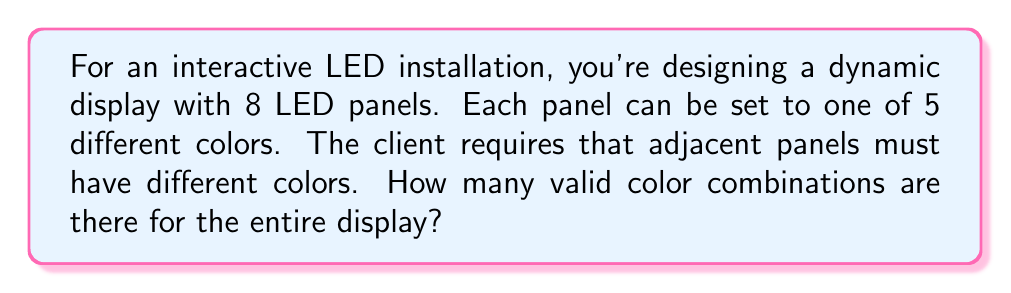Provide a solution to this math problem. Let's approach this step-by-step:

1) First, we need to understand that this is a problem of coloring with restrictions. We have 8 panels in a row, and adjacent panels must have different colors.

2) For the first panel, we have 5 color choices.

3) For each subsequent panel, we can use any color except the one used for the previous panel. So, for each of these panels, we have 4 choices.

4) This scenario can be represented by the multiplication principle. We multiply the number of choices for each panel:

   $$ 5 \cdot 4 \cdot 4 \cdot 4 \cdot 4 \cdot 4 \cdot 4 \cdot 4 $$

5) This can be simplified to:

   $$ 5 \cdot 4^7 $$

6) Let's calculate this:
   $$ 5 \cdot 4^7 = 5 \cdot 16384 = 81920 $$

Therefore, there are 81,920 valid color combinations for the LED display.
Answer: 81,920 